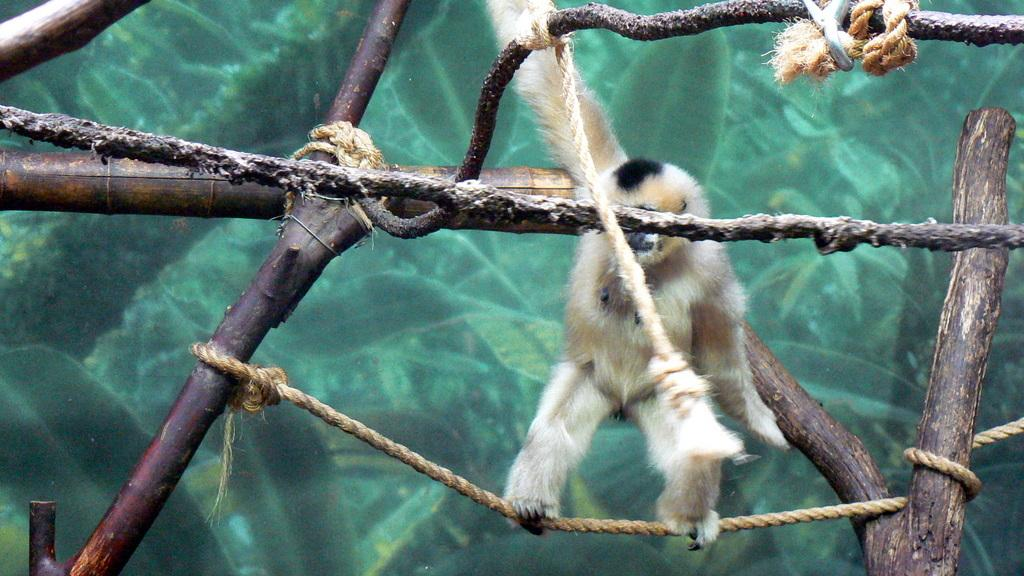What type of animal is in the image? There is a gibbon in the image. What is the gibbon doing in the image? The gibbon is standing on a rope and holding another rope. What type of corn can be seen growing in the image? There is no corn present in the image; it features a gibbon standing on a rope and holding another rope. 